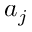Convert formula to latex. <formula><loc_0><loc_0><loc_500><loc_500>a _ { j }</formula> 